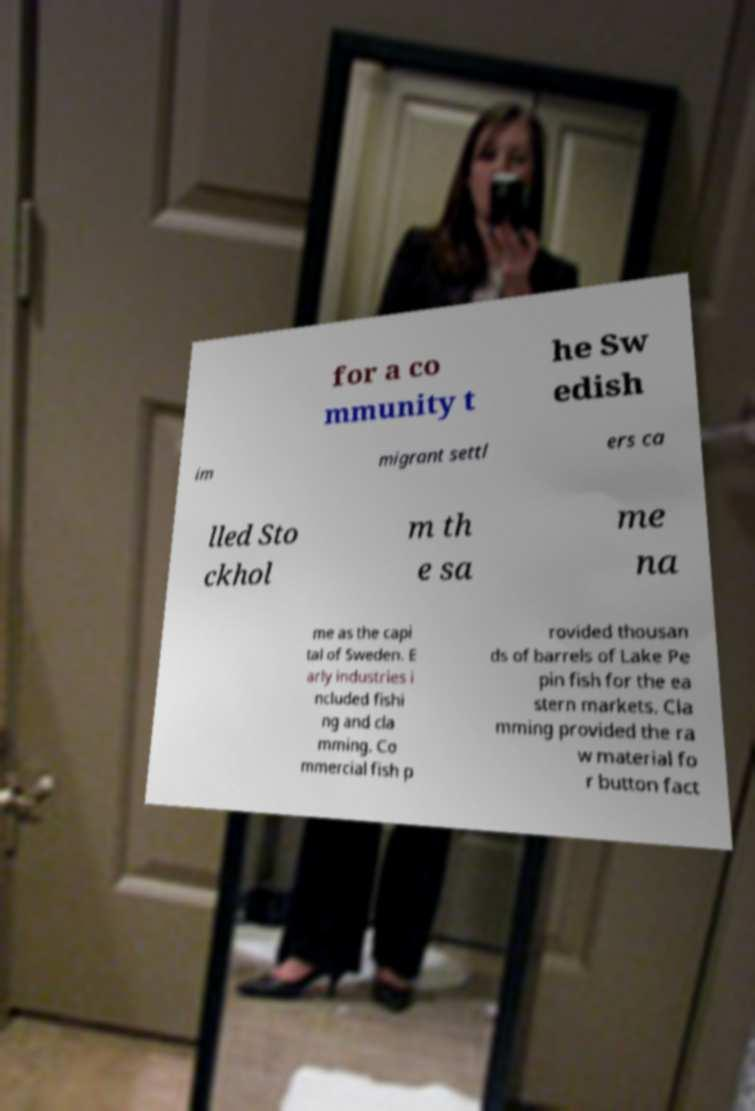Please identify and transcribe the text found in this image. for a co mmunity t he Sw edish im migrant settl ers ca lled Sto ckhol m th e sa me na me as the capi tal of Sweden. E arly industries i ncluded fishi ng and cla mming. Co mmercial fish p rovided thousan ds of barrels of Lake Pe pin fish for the ea stern markets. Cla mming provided the ra w material fo r button fact 